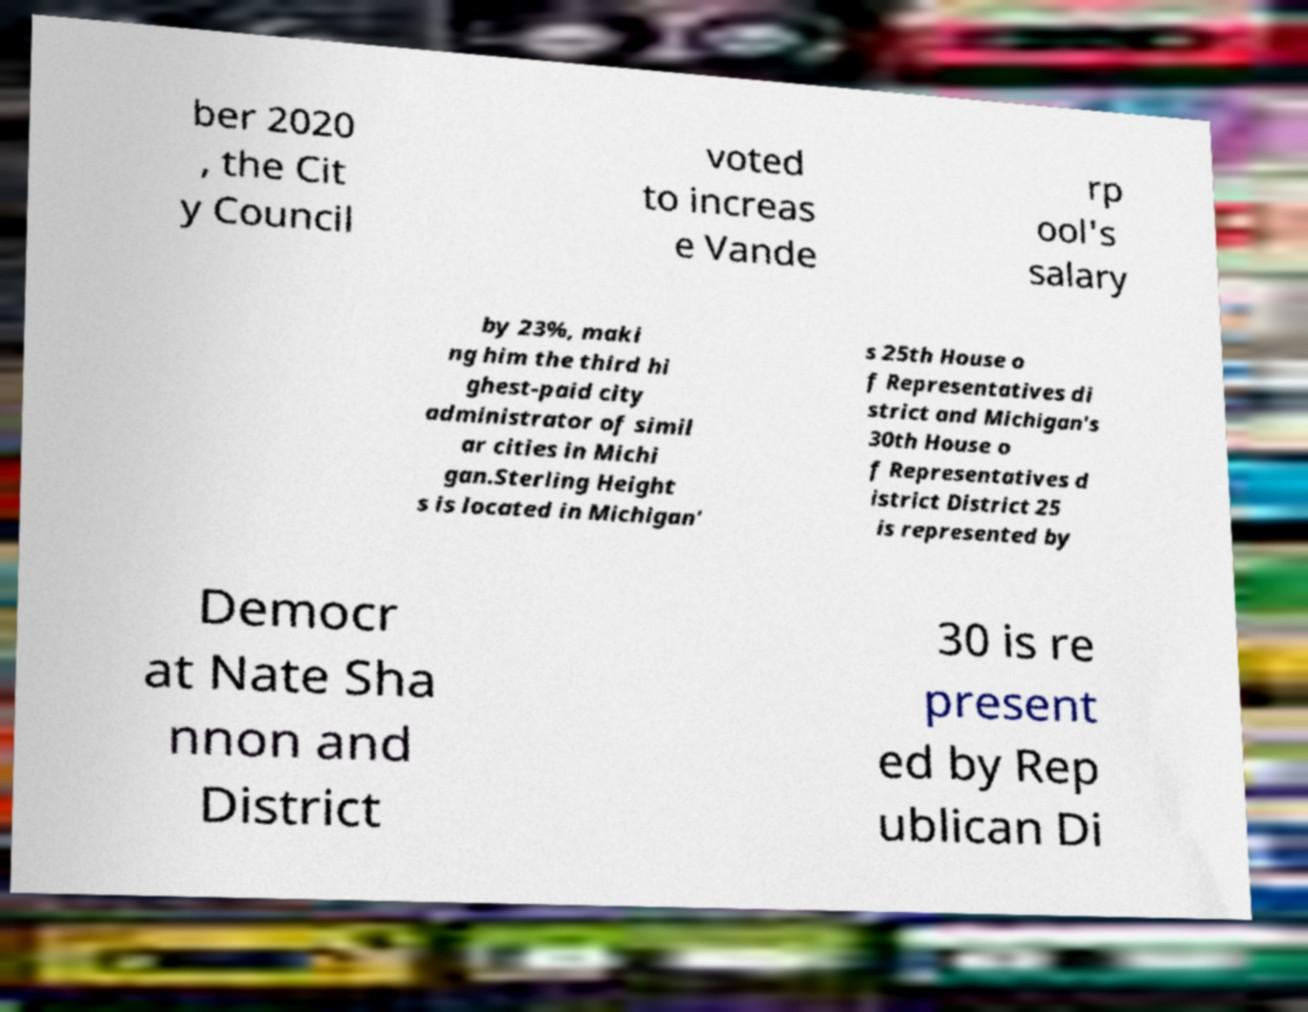I need the written content from this picture converted into text. Can you do that? ber 2020 , the Cit y Council voted to increas e Vande rp ool's salary by 23%, maki ng him the third hi ghest-paid city administrator of simil ar cities in Michi gan.Sterling Height s is located in Michigan' s 25th House o f Representatives di strict and Michigan's 30th House o f Representatives d istrict District 25 is represented by Democr at Nate Sha nnon and District 30 is re present ed by Rep ublican Di 